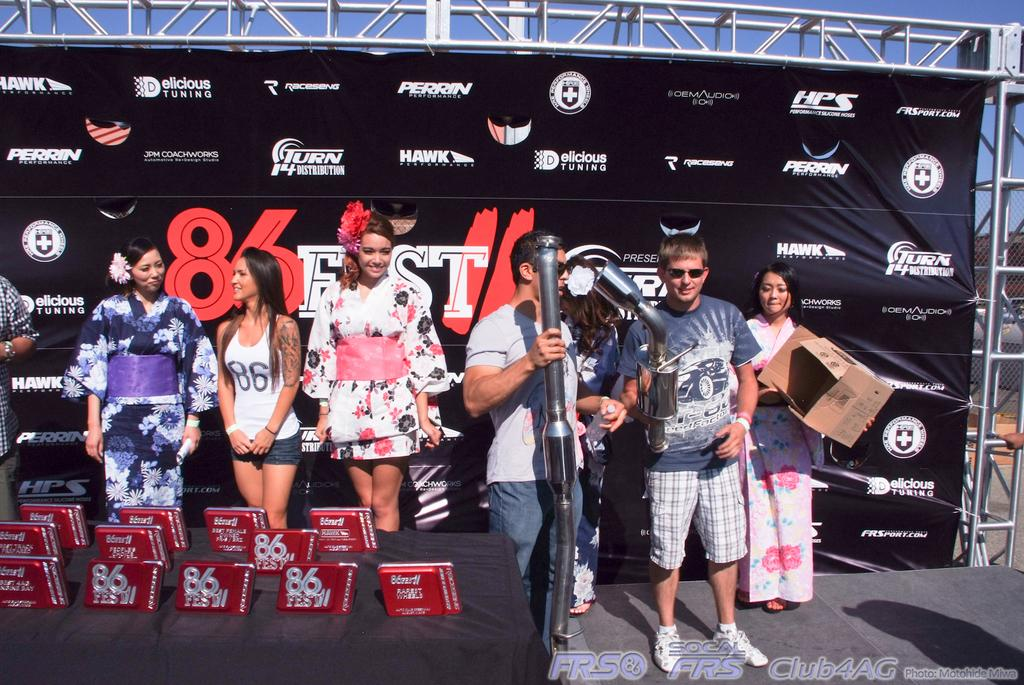<image>
Summarize the visual content of the image. A number of people stand on a stage at 86Fest. 